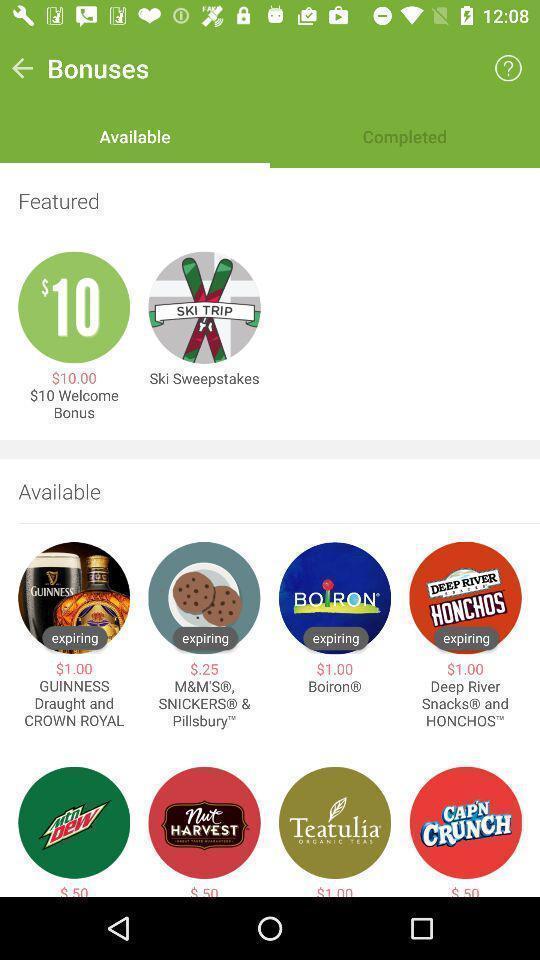Describe this image in words. Screen shows multiple options. 